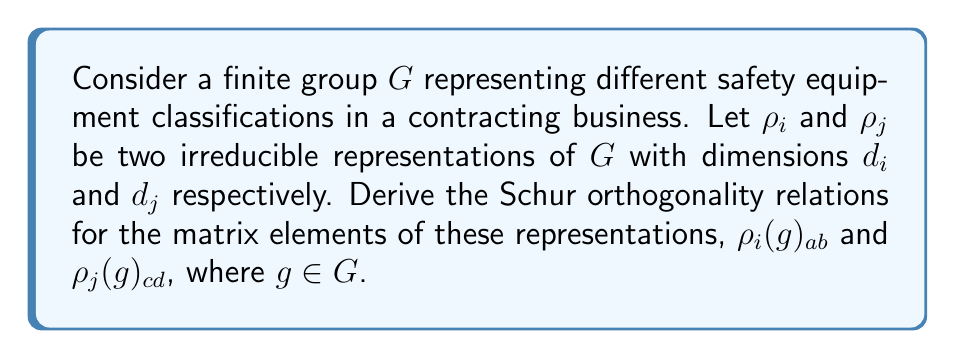Teach me how to tackle this problem. 1. Let's start with the general form of Schur's orthogonality relations:

   $$\frac{1}{|G|} \sum_{g \in G} \rho_i(g)_{ab} \overline{\rho_j(g)_{cd}} = \frac{1}{d_i} \delta_{ij} \delta_{ac} \delta_{bd}$$

2. In the context of safety equipment classifications:
   - $G$ represents different categories of safety equipment
   - $\rho_i$ and $\rho_j$ are irreducible representations of these classifications
   - $d_i$ and $d_j$ are the dimensions of these representations

3. To derive this relation:
   a) Consider the character inner product: $\langle \chi_i, \chi_j \rangle = \delta_{ij}$
   
   b) Expand this using the definition of characters:
      $$\frac{1}{|G|} \sum_{g \in G} \text{Tr}(\rho_i(g)) \overline{\text{Tr}(\rho_j(g))} = \delta_{ij}$$

   c) Express the traces in terms of matrix elements:
      $$\frac{1}{|G|} \sum_{g \in G} \sum_{a=1}^{d_i} \sum_{c=1}^{d_j} \rho_i(g)_{aa} \overline{\rho_j(g)_{cc}} = \delta_{ij}$$

   d) Apply the property of irreducible representations:
      $$\sum_{a=1}^{d_i} \sum_{c=1}^{d_j} \frac{1}{|G|} \sum_{g \in G} \rho_i(g)_{aa} \overline{\rho_j(g)_{cc}} = \delta_{ij}$$

   e) The left side must be zero when $i \neq j$, and equal to 1 when $i = j$. This leads to:
      $$\frac{1}{|G|} \sum_{g \in G} \rho_i(g)_{ab} \overline{\rho_j(g)_{cd}} = \frac{1}{d_i} \delta_{ij} \delta_{ac} \delta_{bd}$$

4. Interpretation for safety equipment:
   - This relation ensures that different classifications of safety equipment (represented by irreducible representations) are orthogonal to each other.
   - It helps in distinguishing between different types of safety equipment and their properties in a mathematical framework.
Answer: $$\frac{1}{|G|} \sum_{g \in G} \rho_i(g)_{ab} \overline{\rho_j(g)_{cd}} = \frac{1}{d_i} \delta_{ij} \delta_{ac} \delta_{bd}$$ 